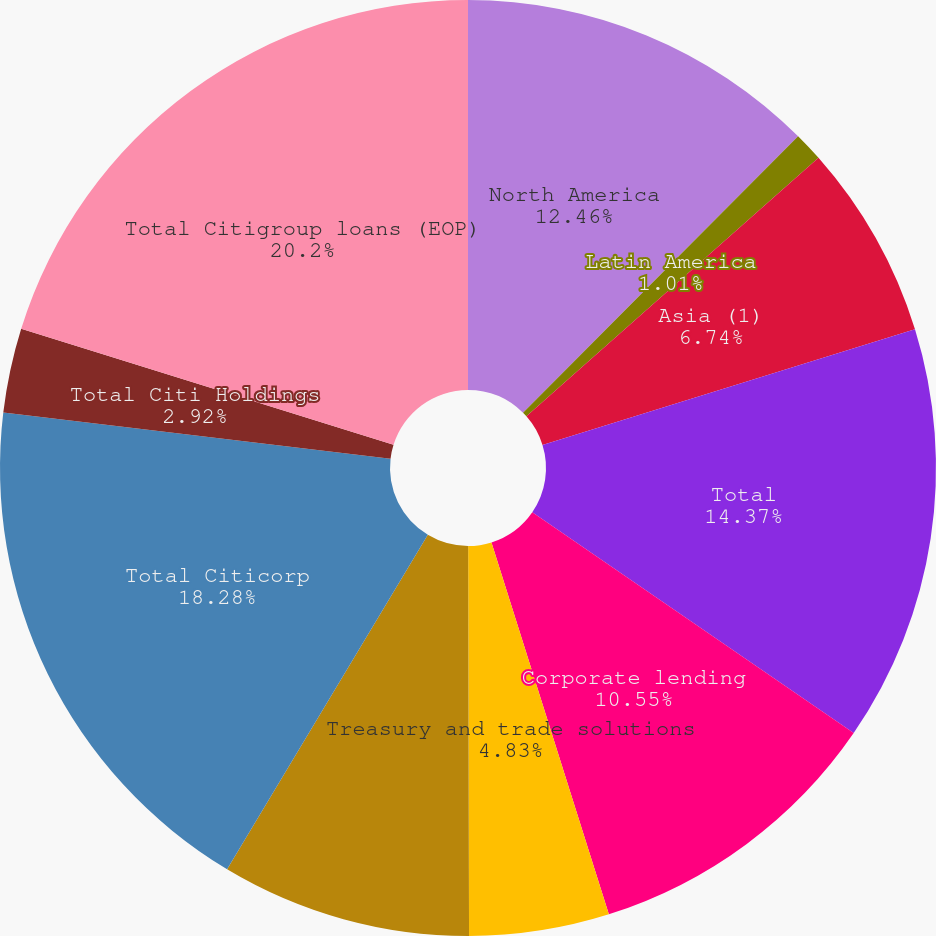<chart> <loc_0><loc_0><loc_500><loc_500><pie_chart><fcel>North America<fcel>Latin America<fcel>Asia (1)<fcel>Total<fcel>Corporate lending<fcel>Treasury and trade solutions<fcel>Private bank markets and<fcel>Total Citicorp<fcel>Total Citi Holdings<fcel>Total Citigroup loans (EOP)<nl><fcel>12.46%<fcel>1.01%<fcel>6.74%<fcel>14.37%<fcel>10.55%<fcel>4.83%<fcel>8.64%<fcel>18.28%<fcel>2.92%<fcel>20.19%<nl></chart> 